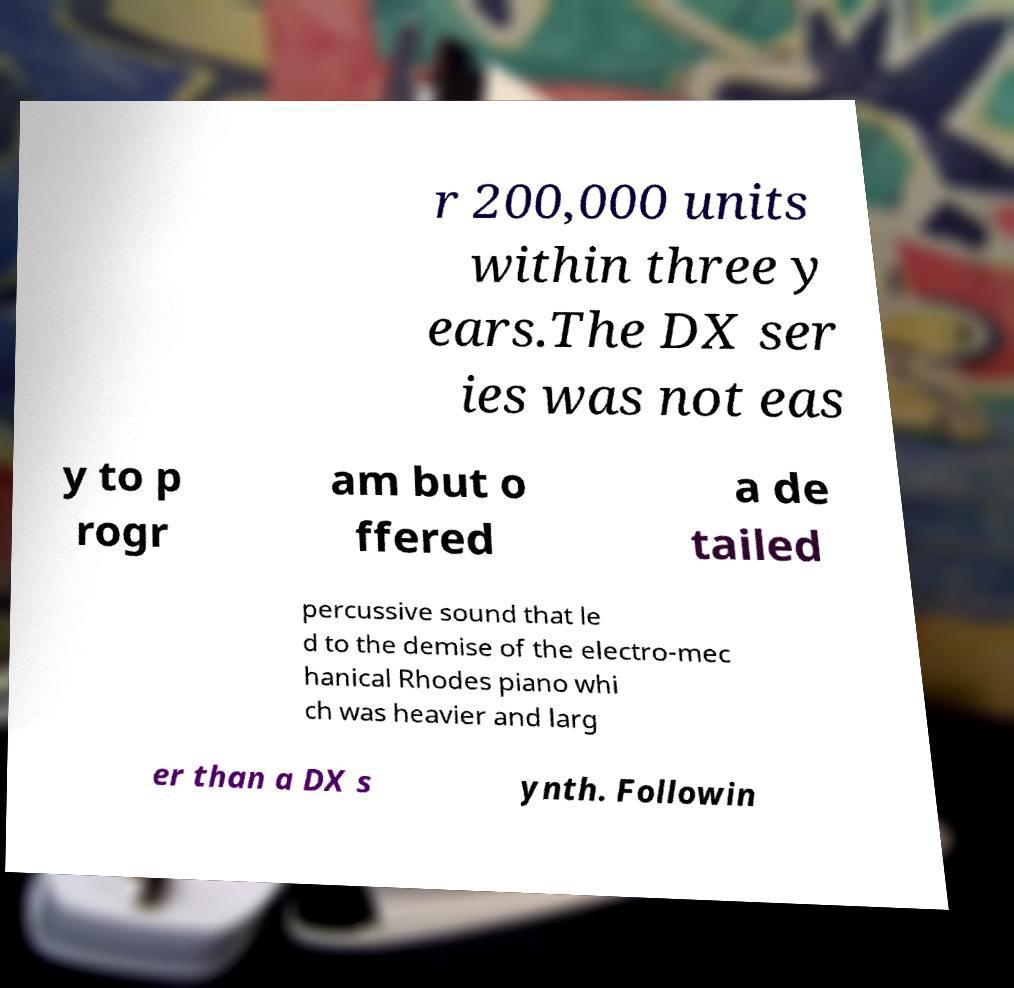Can you read and provide the text displayed in the image?This photo seems to have some interesting text. Can you extract and type it out for me? r 200,000 units within three y ears.The DX ser ies was not eas y to p rogr am but o ffered a de tailed percussive sound that le d to the demise of the electro-mec hanical Rhodes piano whi ch was heavier and larg er than a DX s ynth. Followin 